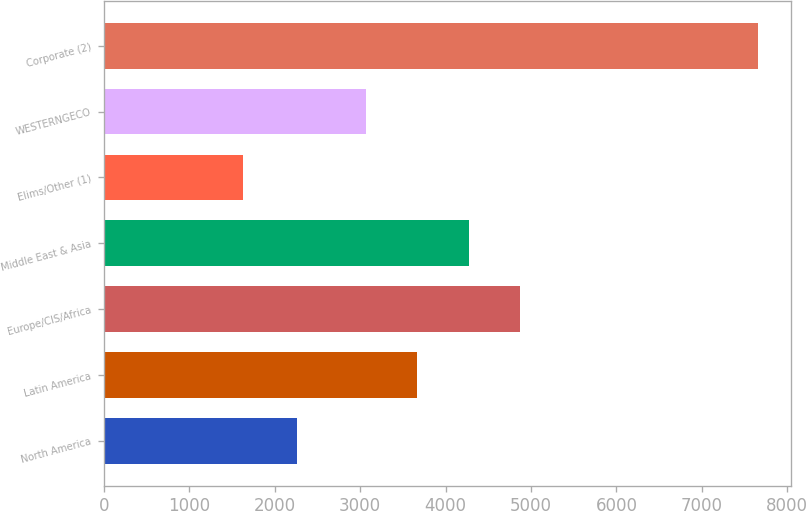Convert chart to OTSL. <chart><loc_0><loc_0><loc_500><loc_500><bar_chart><fcel>North America<fcel>Latin America<fcel>Europe/CIS/Africa<fcel>Middle East & Asia<fcel>Elims/Other (1)<fcel>WESTERNGECO<fcel>Corporate (2)<nl><fcel>2264<fcel>3668<fcel>4874<fcel>4271<fcel>1630<fcel>3065<fcel>7660<nl></chart> 